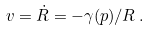<formula> <loc_0><loc_0><loc_500><loc_500>v = \dot { R } = - \gamma ( p ) / R \, .</formula> 